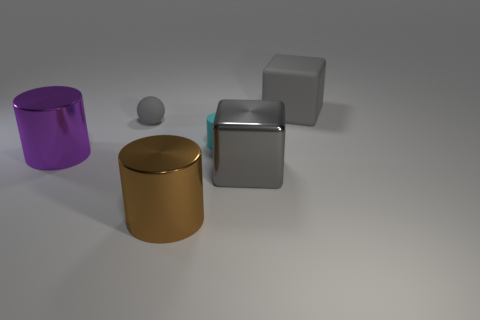What is the shape of the large gray object on the left side of the big thing behind the tiny matte cylinder? The large gray object on the left has a cube-like shape, featuring equal squares for its visible sides and sharp edges, typical characteristics of a cube. 